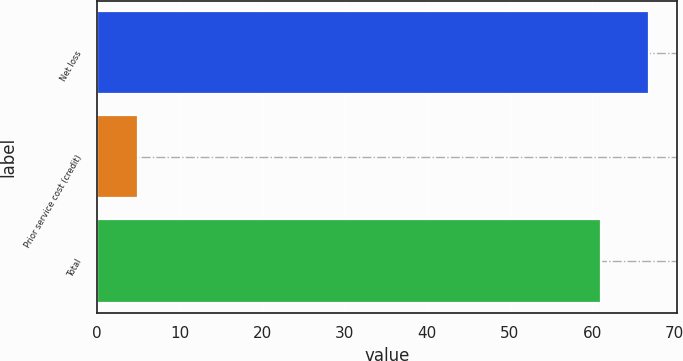<chart> <loc_0><loc_0><loc_500><loc_500><bar_chart><fcel>Net loss<fcel>Prior service cost (credit)<fcel>Total<nl><fcel>66.9<fcel>5<fcel>61<nl></chart> 